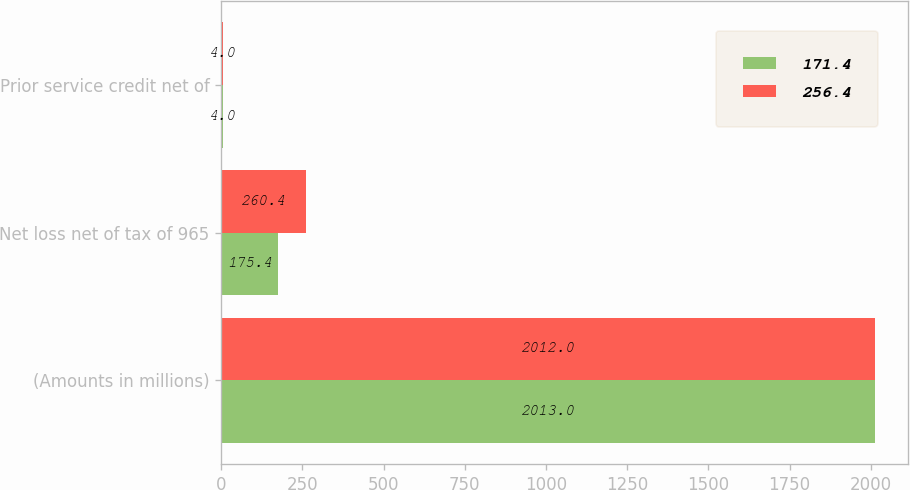<chart> <loc_0><loc_0><loc_500><loc_500><stacked_bar_chart><ecel><fcel>(Amounts in millions)<fcel>Net loss net of tax of 965<fcel>Prior service credit net of<nl><fcel>171.4<fcel>2013<fcel>175.4<fcel>4<nl><fcel>256.4<fcel>2012<fcel>260.4<fcel>4<nl></chart> 